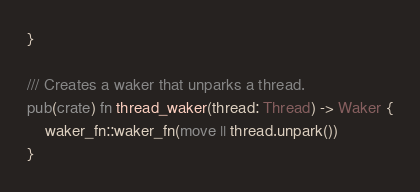Convert code to text. <code><loc_0><loc_0><loc_500><loc_500><_Rust_>}

/// Creates a waker that unparks a thread.
pub(crate) fn thread_waker(thread: Thread) -> Waker {
    waker_fn::waker_fn(move || thread.unpark())
}
</code> 